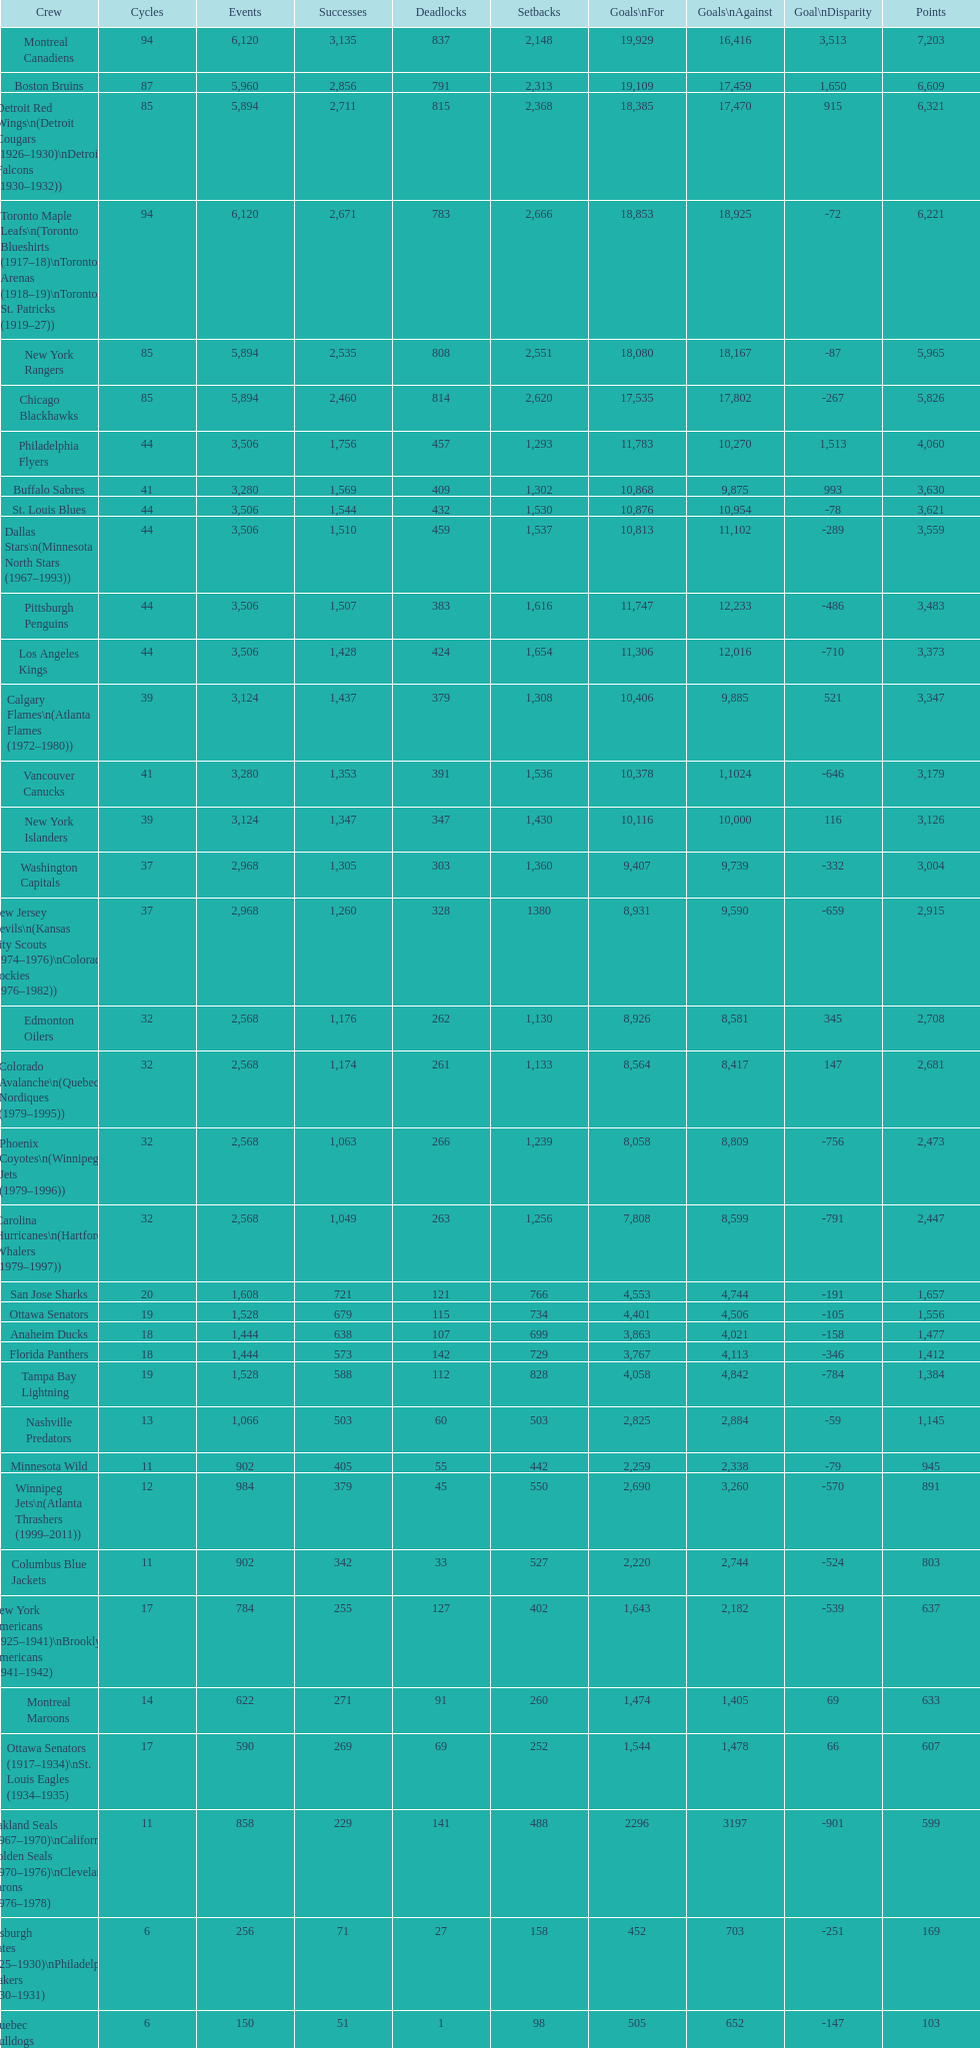Which team was last in terms of points up until this point? Montreal Wanderers. 